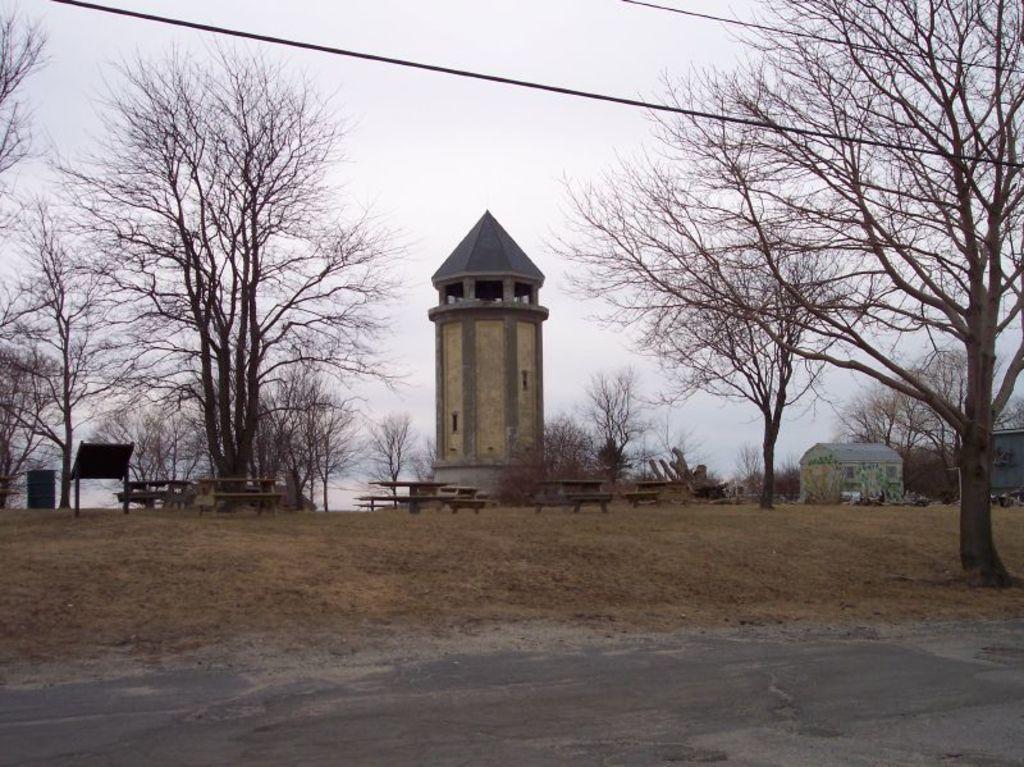Describe this image in one or two sentences. This picture is clicked outside the city. At the bottom of the picture, we see a road and grass. We even see benches and garbage bin. Behind that, we see a tower and a hut. There are many trees in the background. At the top of the picture, we see the sky and the wires. 